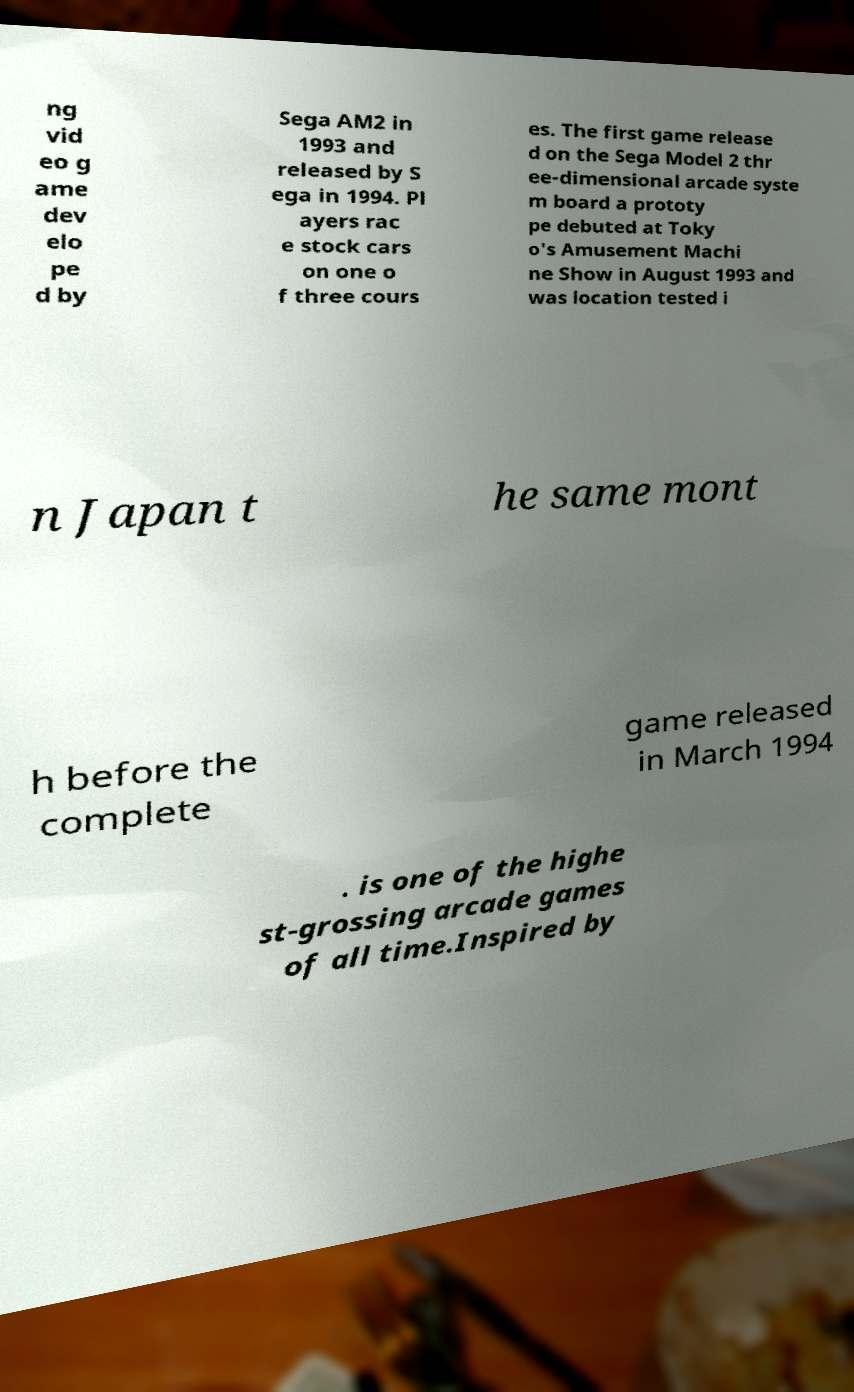For documentation purposes, I need the text within this image transcribed. Could you provide that? ng vid eo g ame dev elo pe d by Sega AM2 in 1993 and released by S ega in 1994. Pl ayers rac e stock cars on one o f three cours es. The first game release d on the Sega Model 2 thr ee-dimensional arcade syste m board a prototy pe debuted at Toky o's Amusement Machi ne Show in August 1993 and was location tested i n Japan t he same mont h before the complete game released in March 1994 . is one of the highe st-grossing arcade games of all time.Inspired by 